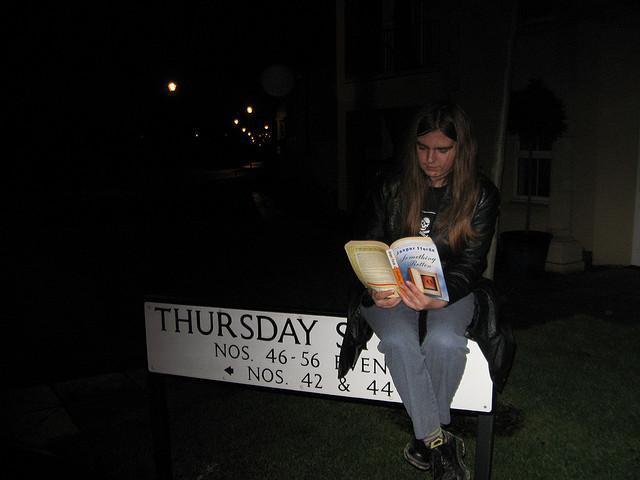How many different colors is the girl wearing?
Give a very brief answer. 2. How many books can you see?
Give a very brief answer. 1. 